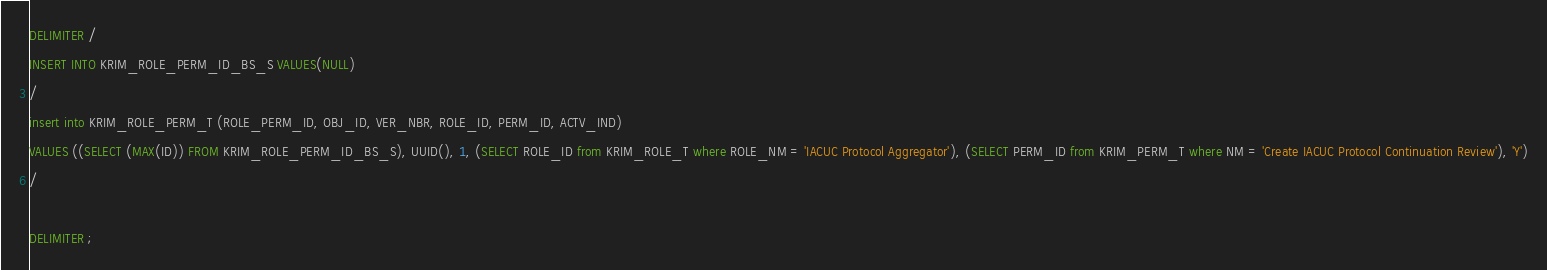Convert code to text. <code><loc_0><loc_0><loc_500><loc_500><_SQL_>DELIMITER /
INSERT INTO KRIM_ROLE_PERM_ID_BS_S VALUES(NULL)
/
insert into KRIM_ROLE_PERM_T (ROLE_PERM_ID, OBJ_ID, VER_NBR, ROLE_ID, PERM_ID, ACTV_IND) 
VALUES ((SELECT (MAX(ID)) FROM KRIM_ROLE_PERM_ID_BS_S), UUID(), 1, (SELECT ROLE_ID from KRIM_ROLE_T where ROLE_NM = 'IACUC Protocol Aggregator'), (SELECT PERM_ID from KRIM_PERM_T where NM = 'Create IACUC Protocol Continuation Review'), 'Y')
/

DELIMITER ;
</code> 